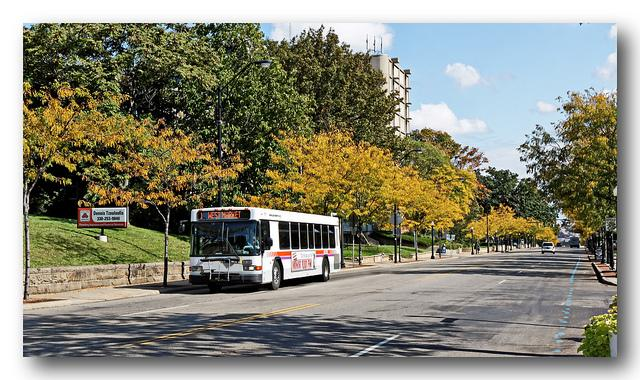What color is the line on the floor that is all the way to the right? Please explain your reasoning. blue. The line on the right is blue. 